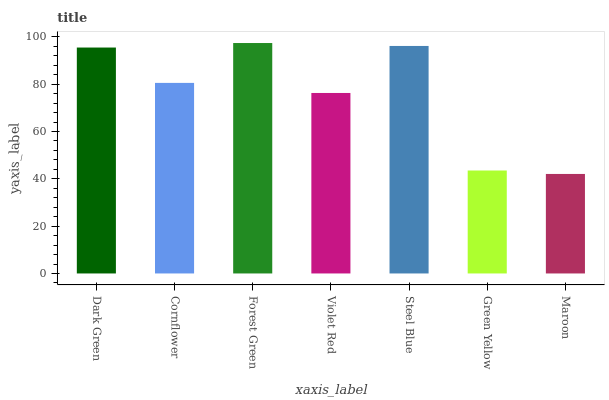Is Maroon the minimum?
Answer yes or no. Yes. Is Forest Green the maximum?
Answer yes or no. Yes. Is Cornflower the minimum?
Answer yes or no. No. Is Cornflower the maximum?
Answer yes or no. No. Is Dark Green greater than Cornflower?
Answer yes or no. Yes. Is Cornflower less than Dark Green?
Answer yes or no. Yes. Is Cornflower greater than Dark Green?
Answer yes or no. No. Is Dark Green less than Cornflower?
Answer yes or no. No. Is Cornflower the high median?
Answer yes or no. Yes. Is Cornflower the low median?
Answer yes or no. Yes. Is Dark Green the high median?
Answer yes or no. No. Is Forest Green the low median?
Answer yes or no. No. 